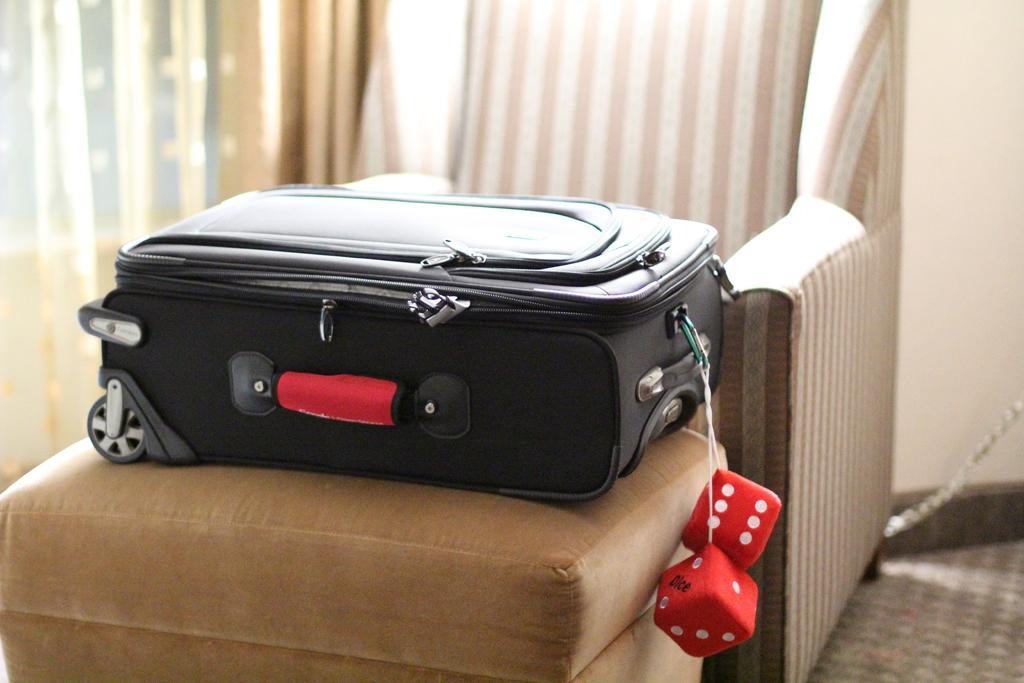Please provide a concise description of this image. In this picture there is a black suitcase placed on top of a brown color sofa and two dices are attached to it. In the background we observe a curtain and a black sofa 